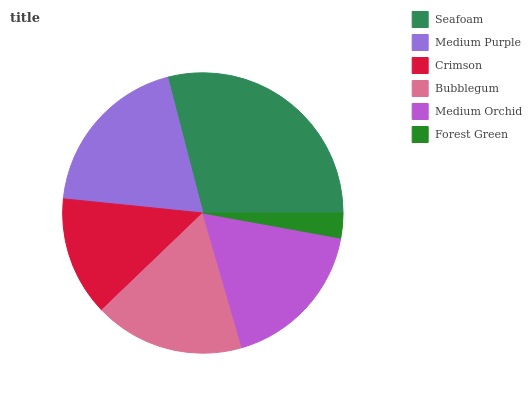Is Forest Green the minimum?
Answer yes or no. Yes. Is Seafoam the maximum?
Answer yes or no. Yes. Is Medium Purple the minimum?
Answer yes or no. No. Is Medium Purple the maximum?
Answer yes or no. No. Is Seafoam greater than Medium Purple?
Answer yes or no. Yes. Is Medium Purple less than Seafoam?
Answer yes or no. Yes. Is Medium Purple greater than Seafoam?
Answer yes or no. No. Is Seafoam less than Medium Purple?
Answer yes or no. No. Is Medium Orchid the high median?
Answer yes or no. Yes. Is Bubblegum the low median?
Answer yes or no. Yes. Is Crimson the high median?
Answer yes or no. No. Is Medium Orchid the low median?
Answer yes or no. No. 